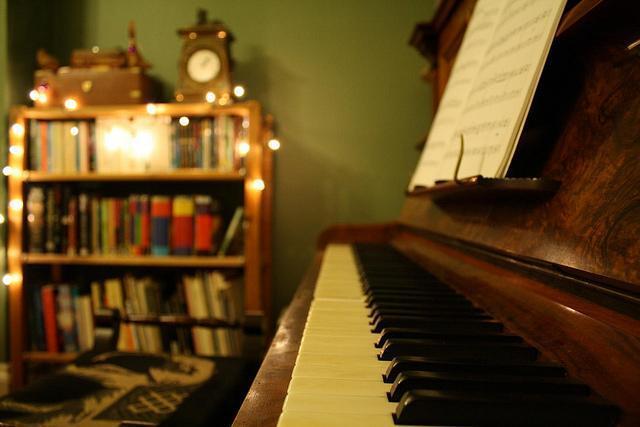How many books can be seen?
Give a very brief answer. 5. 